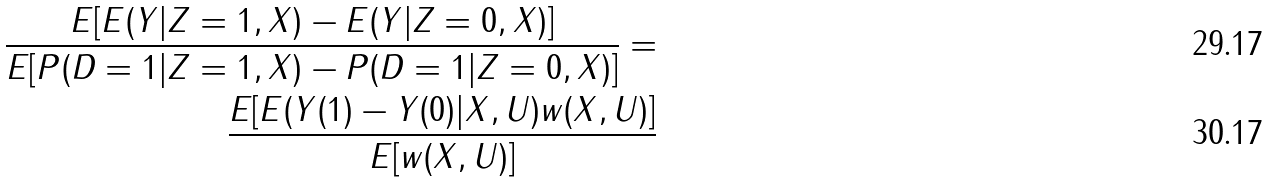Convert formula to latex. <formula><loc_0><loc_0><loc_500><loc_500>\frac { E [ E ( Y | Z = 1 , { X } ) - E ( Y | Z = 0 , { X } ) ] } { E [ P ( D = 1 | Z = 1 , { X } ) - P ( D = 1 | Z = 0 , { X } ) ] } = \\ \frac { E [ E ( Y ( 1 ) - Y ( 0 ) | { X } , { U } ) w ( { X } , { U } ) ] } { E [ w ( { X } , { U } ) ] }</formula> 